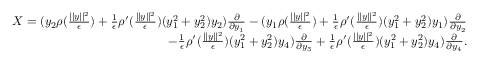<formula> <loc_0><loc_0><loc_500><loc_500>\begin{array} { r } { X = ( y _ { 2 } \rho ( \frac { | | y | | ^ { 2 } } { \epsilon } ) + \frac { 1 } { \epsilon } \rho ^ { \prime } ( \frac { | | y | | ^ { 2 } } { \epsilon } ) ( y _ { 1 } ^ { 2 } + y _ { 2 } ^ { 2 } ) y _ { 2 } ) \frac { \partial } { \partial y _ { 1 } } - ( y _ { 1 } \rho ( \frac { | | y | | ^ { 2 } } { \epsilon } ) + \frac { 1 } { \epsilon } \rho ^ { \prime } ( \frac { | | y | | ^ { 2 } } { \epsilon } ) ( y _ { 1 } ^ { 2 } + y _ { 2 } ^ { 2 } ) y _ { 1 } ) \frac { \partial } { \partial y _ { 2 } } } \\ { - \frac { 1 } { \epsilon } \rho ^ { \prime } ( \frac { | | y | | ^ { 2 } } { \epsilon } ) ( y _ { 1 } ^ { 2 } + y _ { 2 } ^ { 2 } ) y _ { 4 } ) \frac { \partial } { \partial y _ { 3 } } + \frac { 1 } { \epsilon } \rho ^ { \prime } ( \frac { | | y | | ^ { 2 } } { \epsilon } ) ( y _ { 1 } ^ { 2 } + y _ { 2 } ^ { 2 } ) y _ { 4 } ) \frac { \partial } { \partial y _ { 4 } } . } \end{array}</formula> 